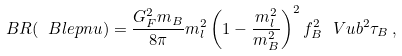<formula> <loc_0><loc_0><loc_500><loc_500>\ B R ( \ B l e p n u ) = \frac { G ^ { 2 } _ { F } m _ { B } } { 8 \pi } m _ { l } ^ { 2 } \left ( 1 - \frac { m ^ { 2 } _ { l } } { m ^ { 2 } _ { B } } \right ) ^ { 2 } f ^ { 2 } _ { B } \ V u b ^ { 2 } \tau _ { B } \, ,</formula> 